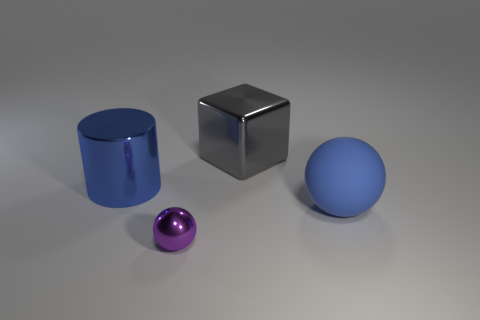Subtract all purple spheres. How many spheres are left? 1 Add 3 blue cylinders. How many objects exist? 7 Subtract all cubes. How many objects are left? 3 Subtract all gray cylinders. How many blue spheres are left? 1 Add 3 purple metal things. How many purple metal things are left? 4 Add 3 large matte objects. How many large matte objects exist? 4 Subtract 0 brown blocks. How many objects are left? 4 Subtract all brown balls. Subtract all purple cylinders. How many balls are left? 2 Subtract all green things. Subtract all blue matte objects. How many objects are left? 3 